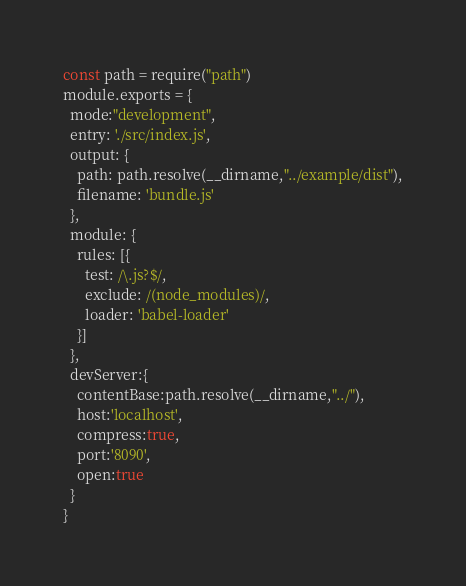Convert code to text. <code><loc_0><loc_0><loc_500><loc_500><_JavaScript_>const path = require("path")
module.exports = {
  mode:"development",
  entry: './src/index.js',
  output: {
    path: path.resolve(__dirname,"../example/dist"),
    filename: 'bundle.js'
  },
  module: {
    rules: [{
      test: /\.js?$/,
      exclude: /(node_modules)/,
      loader: 'babel-loader'
    }]
  },
  devServer:{
    contentBase:path.resolve(__dirname,"../"),
    host:'localhost',
    compress:true,
    port:'8090',
    open:true
  }
}
</code> 